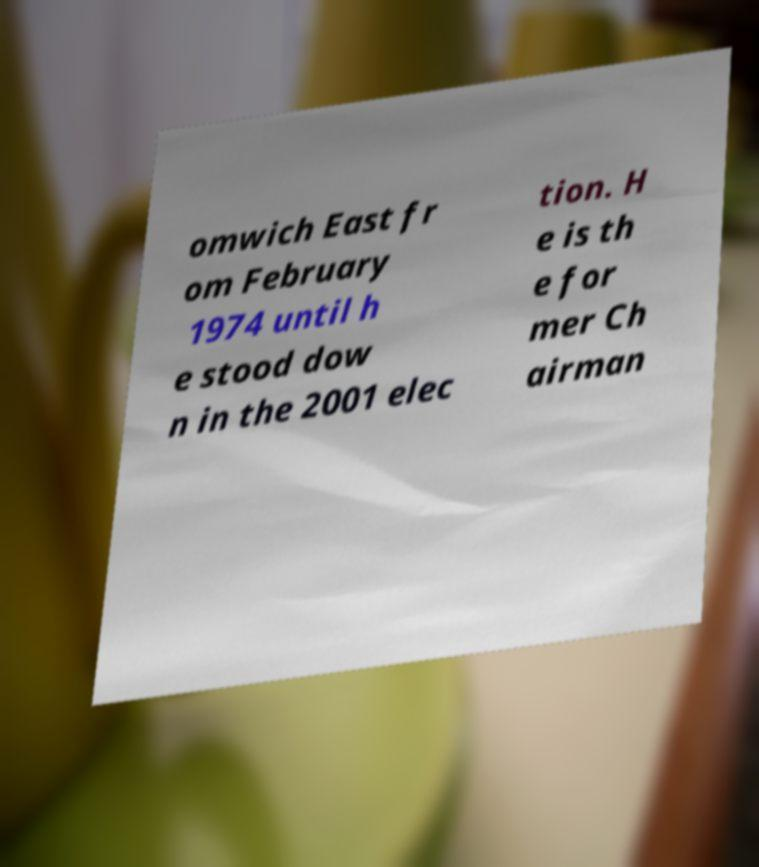What messages or text are displayed in this image? I need them in a readable, typed format. omwich East fr om February 1974 until h e stood dow n in the 2001 elec tion. H e is th e for mer Ch airman 